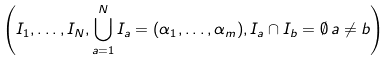<formula> <loc_0><loc_0><loc_500><loc_500>\left ( I _ { 1 } , \dots , I _ { N } , \bigcup _ { a = 1 } ^ { N } I _ { a } = ( \alpha _ { 1 } , \dots , \alpha _ { m } ) , I _ { a } \cap I _ { b } = \emptyset \, a \neq b \right )</formula> 